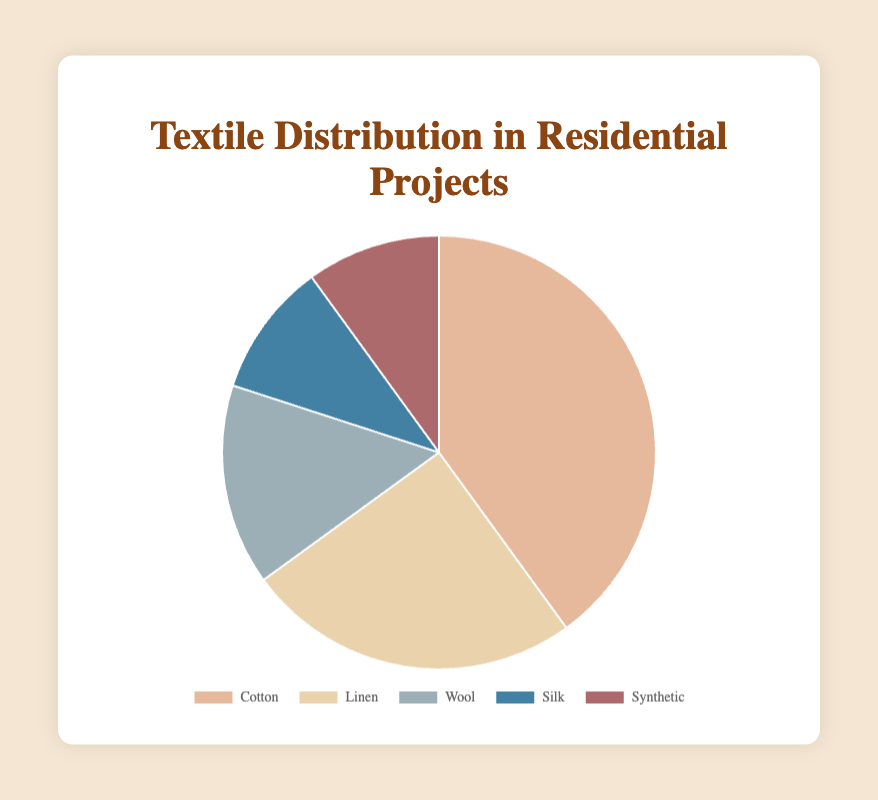What is the most commonly used textile in residential projects? The pie chart shows the distribution percentages of different textiles. Cotton has the largest percentage, which is 40%.
Answer: Cotton Which two textiles have an equal percentage in the distribution? According to the pie chart, Silk and Synthetic both have a percentage of 10%.
Answer: Silk and Synthetic How many textiles have a usage percentage greater than 20%? The pie chart indicates that Cotton has 40% and Linen has 25%, both of which are greater than 20%.
Answer: 2 If you combine the percentages of Wool and Silk, what’s the total percentage? Looking at the pie chart, Wool has 15% and Silk has 10%. Summing these gives 15% + 10% = 25%.
Answer: 25% Which textile is the second most used in residential projects? The pie chart shows that Linen ranks second with a percentage of 25%.
Answer: Linen Is the percentage of Synthetic textile usage greater than or less than the percentage of Wool textile usage? The pie chart indicates that Synthetic has 10% while Wool has 15%. Therefore, Synthetic's usage is less than Wool's.
Answer: Less than What is the total percentage of textiles other than Cotton? The percentages for Linen, Wool, Silk, and Synthetic are 25%, 15%, 10%, and 10% respectively. Summing these gives 25% + 15% + 10% + 10% = 60%.
Answer: 60% Which textile is represented by the color closest to blue on the pie chart? Inspecting the colors on the pie chart, Silk is represented by a shade close to blue.
Answer: Silk How does the percentage of Linen compare to the combined percentage of Silk and Synthetic? Linen has 25%, whereas Silk and Synthetic combined make up 10% + 10% = 20%. Linen's percentage is higher.
Answer: Linen's percentage is higher What is the difference between the highest and lowest textile usage percentages? The highest percentage, given to Cotton, is 40%, and the lowest percentages are for Silk and Synthetic, both at 10%. The difference is 40% - 10% = 30%.
Answer: 30% 